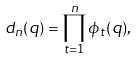Convert formula to latex. <formula><loc_0><loc_0><loc_500><loc_500>d _ { n } ( q ) = \prod _ { t = 1 } ^ { n } \phi _ { t } ( q ) ,</formula> 